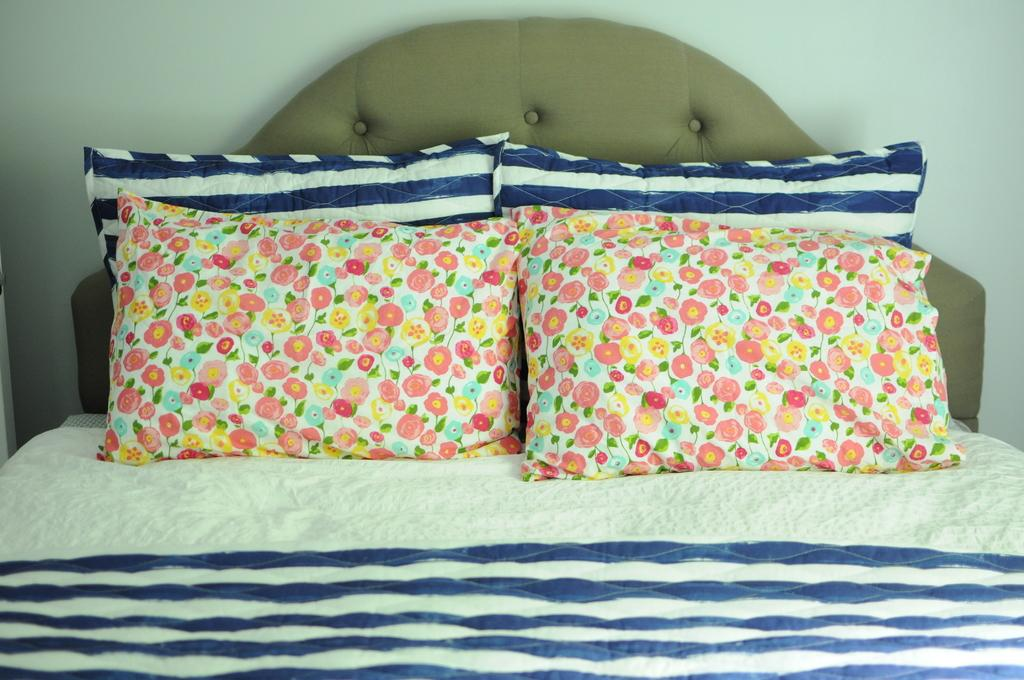What type of furniture is present in the image? There is a bed in the image. What is placed on the bed? There are pillows on the bed. What can be seen on the wall in the image? There is a wall in the image. What type of flag is visible in the park in the image? There is no flag or park present in the image; it only features a bed and pillows. What material is the bed rubbing against in the image? The image does not provide information about the bed rubbing against any material. 